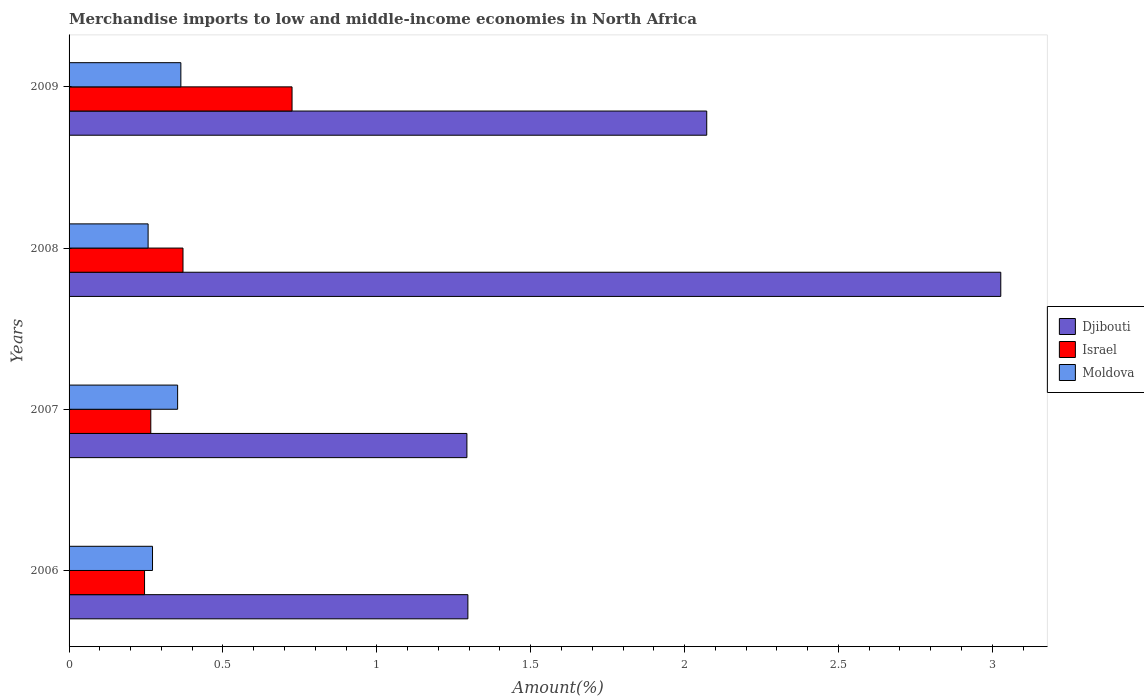Are the number of bars per tick equal to the number of legend labels?
Offer a very short reply. Yes. Are the number of bars on each tick of the Y-axis equal?
Give a very brief answer. Yes. How many bars are there on the 1st tick from the top?
Your answer should be very brief. 3. How many bars are there on the 3rd tick from the bottom?
Provide a short and direct response. 3. What is the label of the 4th group of bars from the top?
Provide a short and direct response. 2006. In how many cases, is the number of bars for a given year not equal to the number of legend labels?
Offer a terse response. 0. What is the percentage of amount earned from merchandise imports in Israel in 2008?
Your answer should be very brief. 0.37. Across all years, what is the maximum percentage of amount earned from merchandise imports in Moldova?
Offer a terse response. 0.36. Across all years, what is the minimum percentage of amount earned from merchandise imports in Djibouti?
Keep it short and to the point. 1.29. In which year was the percentage of amount earned from merchandise imports in Djibouti maximum?
Offer a very short reply. 2008. What is the total percentage of amount earned from merchandise imports in Moldova in the graph?
Provide a succinct answer. 1.24. What is the difference between the percentage of amount earned from merchandise imports in Moldova in 2006 and that in 2008?
Provide a succinct answer. 0.01. What is the difference between the percentage of amount earned from merchandise imports in Israel in 2009 and the percentage of amount earned from merchandise imports in Moldova in 2008?
Ensure brevity in your answer.  0.47. What is the average percentage of amount earned from merchandise imports in Israel per year?
Provide a short and direct response. 0.4. In the year 2007, what is the difference between the percentage of amount earned from merchandise imports in Moldova and percentage of amount earned from merchandise imports in Djibouti?
Offer a very short reply. -0.94. What is the ratio of the percentage of amount earned from merchandise imports in Djibouti in 2007 to that in 2008?
Your answer should be compact. 0.43. What is the difference between the highest and the second highest percentage of amount earned from merchandise imports in Israel?
Keep it short and to the point. 0.35. What is the difference between the highest and the lowest percentage of amount earned from merchandise imports in Djibouti?
Keep it short and to the point. 1.73. In how many years, is the percentage of amount earned from merchandise imports in Israel greater than the average percentage of amount earned from merchandise imports in Israel taken over all years?
Ensure brevity in your answer.  1. Is the sum of the percentage of amount earned from merchandise imports in Djibouti in 2006 and 2008 greater than the maximum percentage of amount earned from merchandise imports in Israel across all years?
Your answer should be compact. Yes. What does the 3rd bar from the top in 2009 represents?
Your answer should be compact. Djibouti. What does the 1st bar from the bottom in 2009 represents?
Ensure brevity in your answer.  Djibouti. Are all the bars in the graph horizontal?
Keep it short and to the point. Yes. What is the difference between two consecutive major ticks on the X-axis?
Your answer should be compact. 0.5. Does the graph contain any zero values?
Give a very brief answer. No. Where does the legend appear in the graph?
Offer a terse response. Center right. How many legend labels are there?
Offer a terse response. 3. How are the legend labels stacked?
Ensure brevity in your answer.  Vertical. What is the title of the graph?
Your response must be concise. Merchandise imports to low and middle-income economies in North Africa. What is the label or title of the X-axis?
Give a very brief answer. Amount(%). What is the Amount(%) in Djibouti in 2006?
Keep it short and to the point. 1.3. What is the Amount(%) in Israel in 2006?
Your answer should be very brief. 0.25. What is the Amount(%) in Moldova in 2006?
Keep it short and to the point. 0.27. What is the Amount(%) in Djibouti in 2007?
Give a very brief answer. 1.29. What is the Amount(%) of Israel in 2007?
Provide a short and direct response. 0.27. What is the Amount(%) in Moldova in 2007?
Ensure brevity in your answer.  0.35. What is the Amount(%) in Djibouti in 2008?
Ensure brevity in your answer.  3.03. What is the Amount(%) in Israel in 2008?
Give a very brief answer. 0.37. What is the Amount(%) in Moldova in 2008?
Give a very brief answer. 0.26. What is the Amount(%) of Djibouti in 2009?
Keep it short and to the point. 2.07. What is the Amount(%) in Israel in 2009?
Offer a terse response. 0.72. What is the Amount(%) of Moldova in 2009?
Your response must be concise. 0.36. Across all years, what is the maximum Amount(%) in Djibouti?
Give a very brief answer. 3.03. Across all years, what is the maximum Amount(%) of Israel?
Your response must be concise. 0.72. Across all years, what is the maximum Amount(%) in Moldova?
Offer a terse response. 0.36. Across all years, what is the minimum Amount(%) of Djibouti?
Ensure brevity in your answer.  1.29. Across all years, what is the minimum Amount(%) of Israel?
Ensure brevity in your answer.  0.25. Across all years, what is the minimum Amount(%) of Moldova?
Make the answer very short. 0.26. What is the total Amount(%) of Djibouti in the graph?
Keep it short and to the point. 7.69. What is the total Amount(%) in Israel in the graph?
Ensure brevity in your answer.  1.61. What is the total Amount(%) in Moldova in the graph?
Provide a short and direct response. 1.24. What is the difference between the Amount(%) of Djibouti in 2006 and that in 2007?
Provide a succinct answer. 0. What is the difference between the Amount(%) of Israel in 2006 and that in 2007?
Make the answer very short. -0.02. What is the difference between the Amount(%) of Moldova in 2006 and that in 2007?
Provide a short and direct response. -0.08. What is the difference between the Amount(%) of Djibouti in 2006 and that in 2008?
Give a very brief answer. -1.73. What is the difference between the Amount(%) of Israel in 2006 and that in 2008?
Give a very brief answer. -0.12. What is the difference between the Amount(%) in Moldova in 2006 and that in 2008?
Ensure brevity in your answer.  0.01. What is the difference between the Amount(%) of Djibouti in 2006 and that in 2009?
Ensure brevity in your answer.  -0.78. What is the difference between the Amount(%) in Israel in 2006 and that in 2009?
Give a very brief answer. -0.48. What is the difference between the Amount(%) in Moldova in 2006 and that in 2009?
Provide a short and direct response. -0.09. What is the difference between the Amount(%) in Djibouti in 2007 and that in 2008?
Offer a terse response. -1.73. What is the difference between the Amount(%) in Israel in 2007 and that in 2008?
Make the answer very short. -0.1. What is the difference between the Amount(%) in Moldova in 2007 and that in 2008?
Provide a short and direct response. 0.1. What is the difference between the Amount(%) in Djibouti in 2007 and that in 2009?
Your answer should be very brief. -0.78. What is the difference between the Amount(%) of Israel in 2007 and that in 2009?
Give a very brief answer. -0.46. What is the difference between the Amount(%) in Moldova in 2007 and that in 2009?
Provide a short and direct response. -0.01. What is the difference between the Amount(%) of Djibouti in 2008 and that in 2009?
Ensure brevity in your answer.  0.96. What is the difference between the Amount(%) of Israel in 2008 and that in 2009?
Give a very brief answer. -0.35. What is the difference between the Amount(%) of Moldova in 2008 and that in 2009?
Ensure brevity in your answer.  -0.11. What is the difference between the Amount(%) in Djibouti in 2006 and the Amount(%) in Israel in 2007?
Offer a very short reply. 1.03. What is the difference between the Amount(%) in Djibouti in 2006 and the Amount(%) in Moldova in 2007?
Your answer should be compact. 0.94. What is the difference between the Amount(%) in Israel in 2006 and the Amount(%) in Moldova in 2007?
Ensure brevity in your answer.  -0.11. What is the difference between the Amount(%) in Djibouti in 2006 and the Amount(%) in Israel in 2008?
Your answer should be compact. 0.93. What is the difference between the Amount(%) in Djibouti in 2006 and the Amount(%) in Moldova in 2008?
Keep it short and to the point. 1.04. What is the difference between the Amount(%) in Israel in 2006 and the Amount(%) in Moldova in 2008?
Give a very brief answer. -0.01. What is the difference between the Amount(%) of Djibouti in 2006 and the Amount(%) of Israel in 2009?
Provide a succinct answer. 0.57. What is the difference between the Amount(%) in Djibouti in 2006 and the Amount(%) in Moldova in 2009?
Provide a short and direct response. 0.93. What is the difference between the Amount(%) in Israel in 2006 and the Amount(%) in Moldova in 2009?
Offer a terse response. -0.12. What is the difference between the Amount(%) of Djibouti in 2007 and the Amount(%) of Israel in 2008?
Provide a succinct answer. 0.92. What is the difference between the Amount(%) of Djibouti in 2007 and the Amount(%) of Moldova in 2008?
Provide a short and direct response. 1.04. What is the difference between the Amount(%) in Israel in 2007 and the Amount(%) in Moldova in 2008?
Ensure brevity in your answer.  0.01. What is the difference between the Amount(%) in Djibouti in 2007 and the Amount(%) in Israel in 2009?
Your answer should be compact. 0.57. What is the difference between the Amount(%) of Djibouti in 2007 and the Amount(%) of Moldova in 2009?
Offer a terse response. 0.93. What is the difference between the Amount(%) in Israel in 2007 and the Amount(%) in Moldova in 2009?
Give a very brief answer. -0.1. What is the difference between the Amount(%) of Djibouti in 2008 and the Amount(%) of Israel in 2009?
Your response must be concise. 2.3. What is the difference between the Amount(%) of Djibouti in 2008 and the Amount(%) of Moldova in 2009?
Provide a succinct answer. 2.66. What is the difference between the Amount(%) of Israel in 2008 and the Amount(%) of Moldova in 2009?
Offer a terse response. 0.01. What is the average Amount(%) in Djibouti per year?
Your response must be concise. 1.92. What is the average Amount(%) of Israel per year?
Your answer should be compact. 0.4. What is the average Amount(%) in Moldova per year?
Ensure brevity in your answer.  0.31. In the year 2006, what is the difference between the Amount(%) in Djibouti and Amount(%) in Israel?
Make the answer very short. 1.05. In the year 2006, what is the difference between the Amount(%) of Djibouti and Amount(%) of Moldova?
Your response must be concise. 1.02. In the year 2006, what is the difference between the Amount(%) of Israel and Amount(%) of Moldova?
Ensure brevity in your answer.  -0.03. In the year 2007, what is the difference between the Amount(%) in Djibouti and Amount(%) in Israel?
Keep it short and to the point. 1.03. In the year 2007, what is the difference between the Amount(%) of Djibouti and Amount(%) of Moldova?
Your answer should be very brief. 0.94. In the year 2007, what is the difference between the Amount(%) in Israel and Amount(%) in Moldova?
Your response must be concise. -0.09. In the year 2008, what is the difference between the Amount(%) of Djibouti and Amount(%) of Israel?
Keep it short and to the point. 2.66. In the year 2008, what is the difference between the Amount(%) in Djibouti and Amount(%) in Moldova?
Provide a short and direct response. 2.77. In the year 2008, what is the difference between the Amount(%) of Israel and Amount(%) of Moldova?
Your response must be concise. 0.11. In the year 2009, what is the difference between the Amount(%) in Djibouti and Amount(%) in Israel?
Keep it short and to the point. 1.35. In the year 2009, what is the difference between the Amount(%) in Djibouti and Amount(%) in Moldova?
Your answer should be compact. 1.71. In the year 2009, what is the difference between the Amount(%) in Israel and Amount(%) in Moldova?
Keep it short and to the point. 0.36. What is the ratio of the Amount(%) of Israel in 2006 to that in 2007?
Offer a terse response. 0.92. What is the ratio of the Amount(%) in Moldova in 2006 to that in 2007?
Provide a short and direct response. 0.77. What is the ratio of the Amount(%) in Djibouti in 2006 to that in 2008?
Make the answer very short. 0.43. What is the ratio of the Amount(%) of Israel in 2006 to that in 2008?
Ensure brevity in your answer.  0.66. What is the ratio of the Amount(%) of Moldova in 2006 to that in 2008?
Offer a terse response. 1.06. What is the ratio of the Amount(%) in Djibouti in 2006 to that in 2009?
Offer a terse response. 0.63. What is the ratio of the Amount(%) in Israel in 2006 to that in 2009?
Your answer should be very brief. 0.34. What is the ratio of the Amount(%) of Moldova in 2006 to that in 2009?
Offer a very short reply. 0.75. What is the ratio of the Amount(%) in Djibouti in 2007 to that in 2008?
Your answer should be compact. 0.43. What is the ratio of the Amount(%) of Israel in 2007 to that in 2008?
Offer a terse response. 0.72. What is the ratio of the Amount(%) in Moldova in 2007 to that in 2008?
Offer a terse response. 1.37. What is the ratio of the Amount(%) of Djibouti in 2007 to that in 2009?
Make the answer very short. 0.62. What is the ratio of the Amount(%) in Israel in 2007 to that in 2009?
Provide a succinct answer. 0.37. What is the ratio of the Amount(%) of Moldova in 2007 to that in 2009?
Your answer should be very brief. 0.97. What is the ratio of the Amount(%) of Djibouti in 2008 to that in 2009?
Offer a terse response. 1.46. What is the ratio of the Amount(%) of Israel in 2008 to that in 2009?
Offer a terse response. 0.51. What is the ratio of the Amount(%) in Moldova in 2008 to that in 2009?
Your answer should be very brief. 0.71. What is the difference between the highest and the second highest Amount(%) of Djibouti?
Ensure brevity in your answer.  0.96. What is the difference between the highest and the second highest Amount(%) of Israel?
Ensure brevity in your answer.  0.35. What is the difference between the highest and the second highest Amount(%) of Moldova?
Give a very brief answer. 0.01. What is the difference between the highest and the lowest Amount(%) of Djibouti?
Offer a terse response. 1.73. What is the difference between the highest and the lowest Amount(%) in Israel?
Your answer should be very brief. 0.48. What is the difference between the highest and the lowest Amount(%) in Moldova?
Keep it short and to the point. 0.11. 